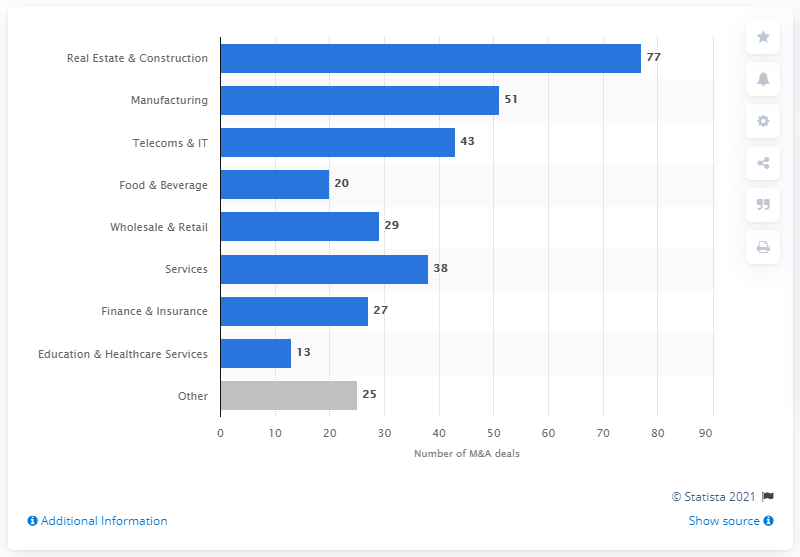Indicate a few pertinent items in this graphic. In 2018, 77 transactions were completed in Poland. In 2018, a total of 51 deals were completed in Poland. 